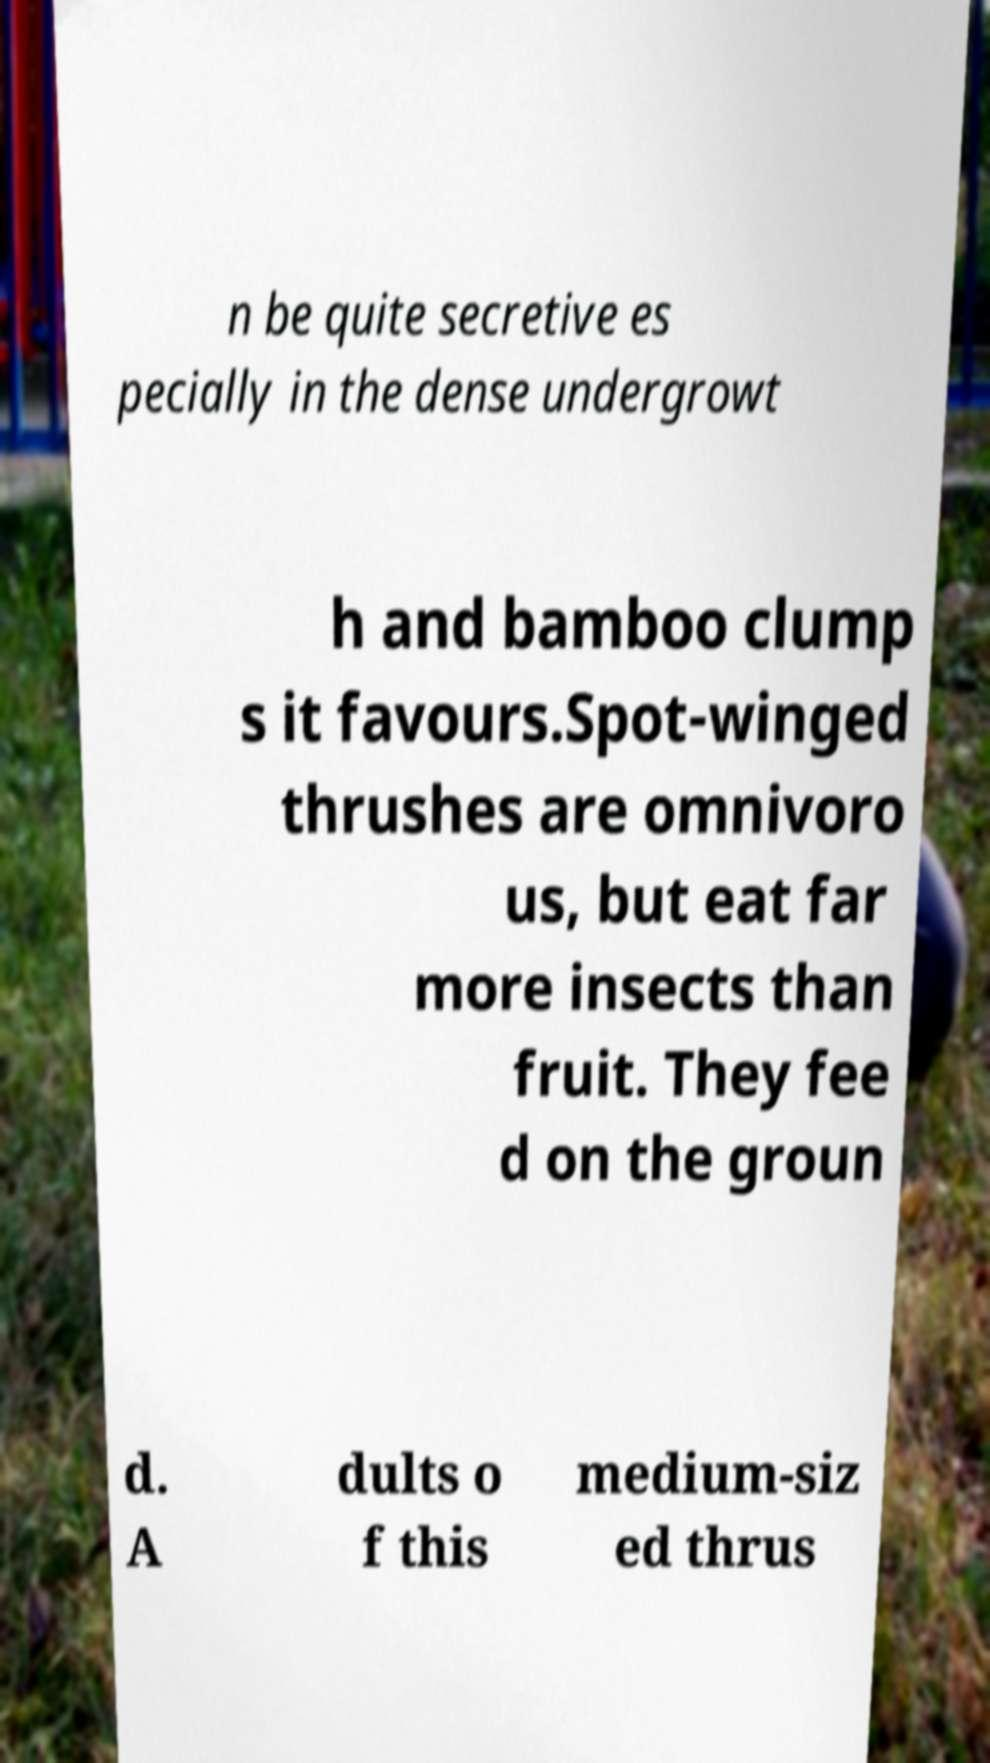Can you accurately transcribe the text from the provided image for me? n be quite secretive es pecially in the dense undergrowt h and bamboo clump s it favours.Spot-winged thrushes are omnivoro us, but eat far more insects than fruit. They fee d on the groun d. A dults o f this medium-siz ed thrus 